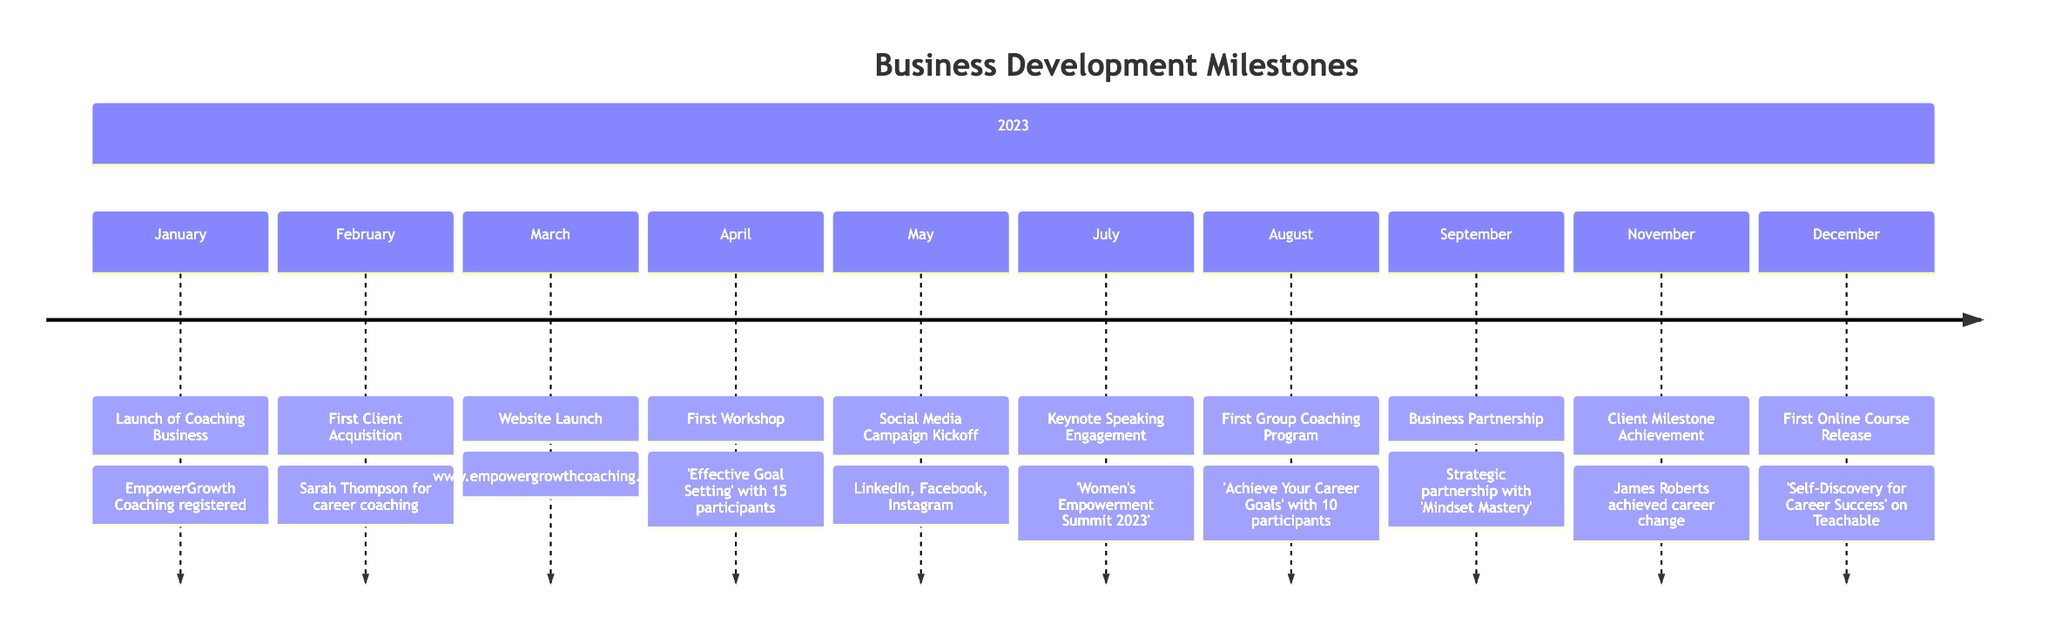What is the date of the Launch of Coaching Business? The diagram lists the milestone "Launch of Coaching Business" with the date "2023-01-15" directly associated with it.
Answer: 2023-01-15 Who was the first client acquired? The first client acquisition milestone specifies "Sarah Thompson" as the first client secured for coaching sessions, which can be found under the corresponding milestone.
Answer: Sarah Thompson What was the first workshop conducted? Referring to the diagram, the first workshop is detailed as occurring on April 12, 2023, with the title "'Effective Goal Setting'."
Answer: 'Effective Goal Setting' How many participants attended the first workshop? The milestone for the first workshop indicates that it had "15 participants", which is explicitly mentioned in the details of that milestone.
Answer: 15 participants What milestone occurred in August 2023? The diagram shows that in August 2023, the "First Group Coaching Program" was launched and details the program's name and participant count, which collectively answer the question.
Answer: First Group Coaching Program Which milestone is related to a keynote speaking engagement? In looking through the diagram, the milestone indicating a keynote speaking engagement is specified under "Keynote Speaking Engagement", with the date "2023-07-18", reflecting its specific connection to that achievement.
Answer: Keynote Speaking Engagement How many clients achieved a milestone by November 2023? The milestone indicates one client, "James Roberts," reached a significant career change by November 10, 2023, emphasizing that only one client is noted for that achievement by that date.
Answer: 1 client What online course was released in December 2023? The milestone for December 5, 2023, identifies the release of an online course titled "'Self-Discovery for Career Success'", which is explicitly mentioned in the milestone details for that date.
Answer: 'Self-Discovery for Career Success' What social media platforms were included in the campaign kickoff? The milestone detailing the "Social Media Campaign Kickoff" lists "LinkedIn, Facebook, and Instagram" as the platforms used, which encompasses all mentioned platforms in this campaign.
Answer: LinkedIn, Facebook, and Instagram 